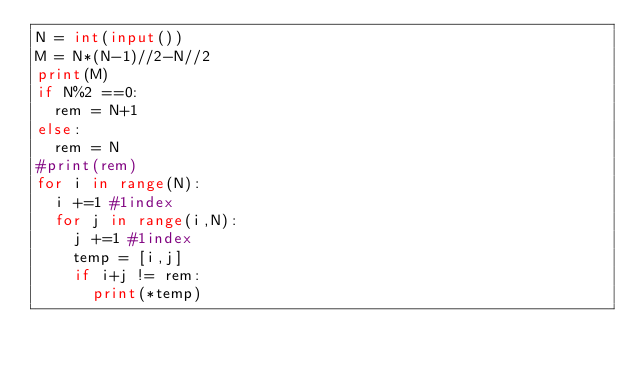Convert code to text. <code><loc_0><loc_0><loc_500><loc_500><_Python_>N = int(input())
M = N*(N-1)//2-N//2
print(M)
if N%2 ==0:
  rem = N+1
else:
  rem = N
#print(rem)
for i in range(N):
  i +=1 #1index
  for j in range(i,N):
    j +=1 #1index
    temp = [i,j]
    if i+j != rem:
      print(*temp)</code> 